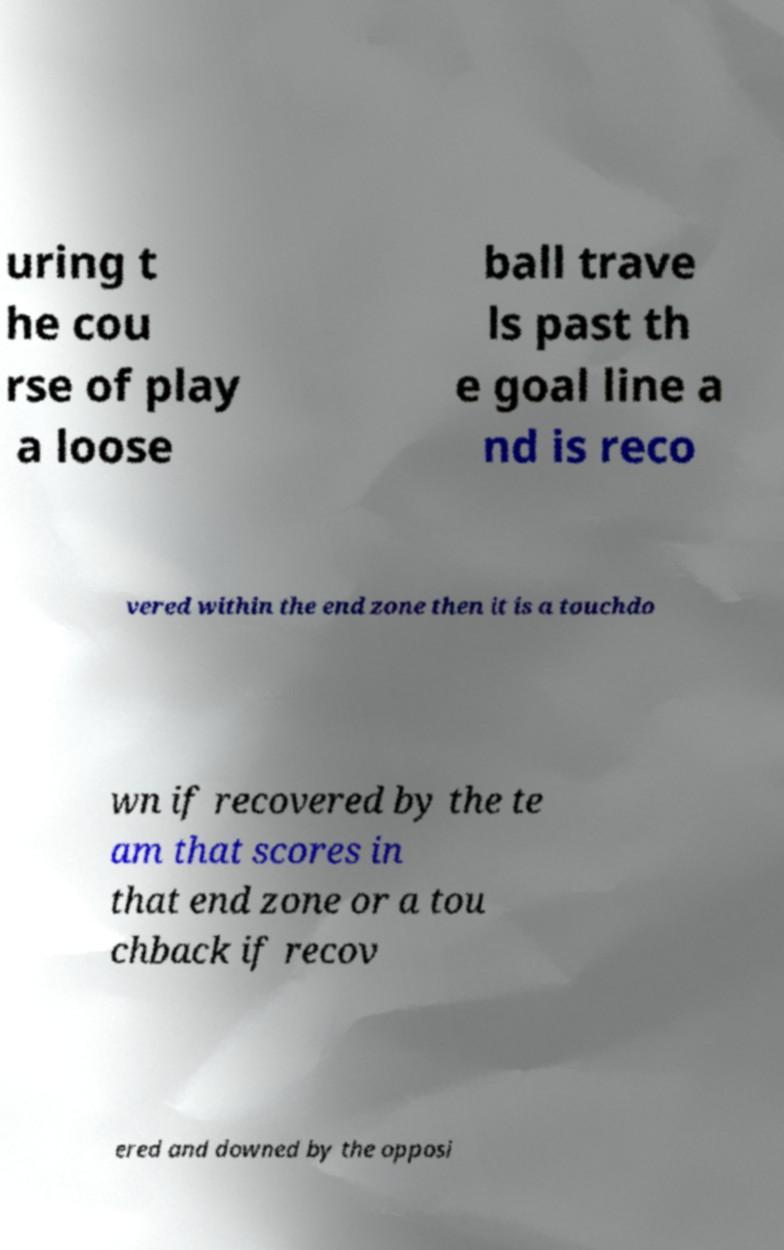Could you extract and type out the text from this image? uring t he cou rse of play a loose ball trave ls past th e goal line a nd is reco vered within the end zone then it is a touchdo wn if recovered by the te am that scores in that end zone or a tou chback if recov ered and downed by the opposi 